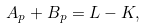<formula> <loc_0><loc_0><loc_500><loc_500>A _ { p } + B _ { p } = L - K ,</formula> 